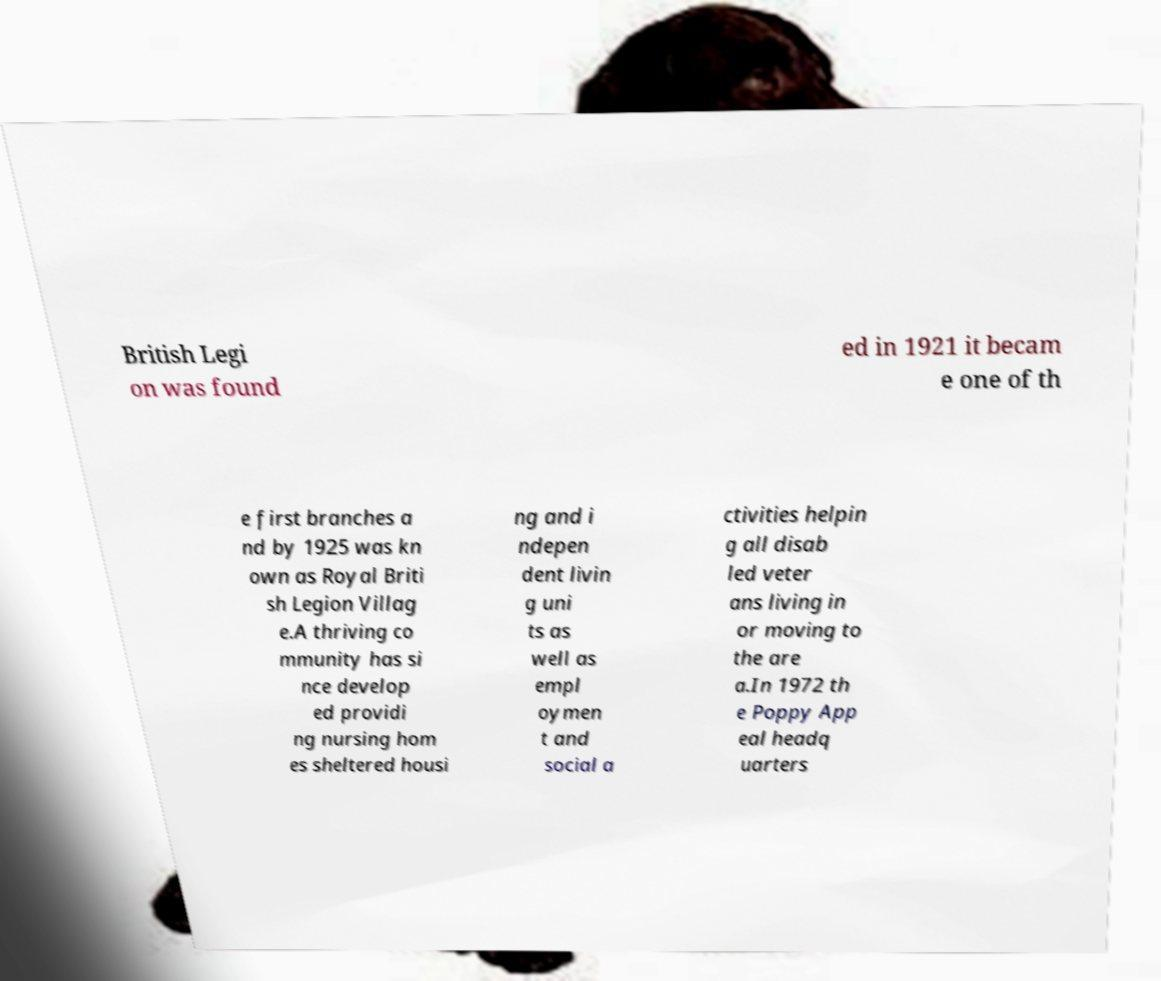Please identify and transcribe the text found in this image. British Legi on was found ed in 1921 it becam e one of th e first branches a nd by 1925 was kn own as Royal Briti sh Legion Villag e.A thriving co mmunity has si nce develop ed providi ng nursing hom es sheltered housi ng and i ndepen dent livin g uni ts as well as empl oymen t and social a ctivities helpin g all disab led veter ans living in or moving to the are a.In 1972 th e Poppy App eal headq uarters 